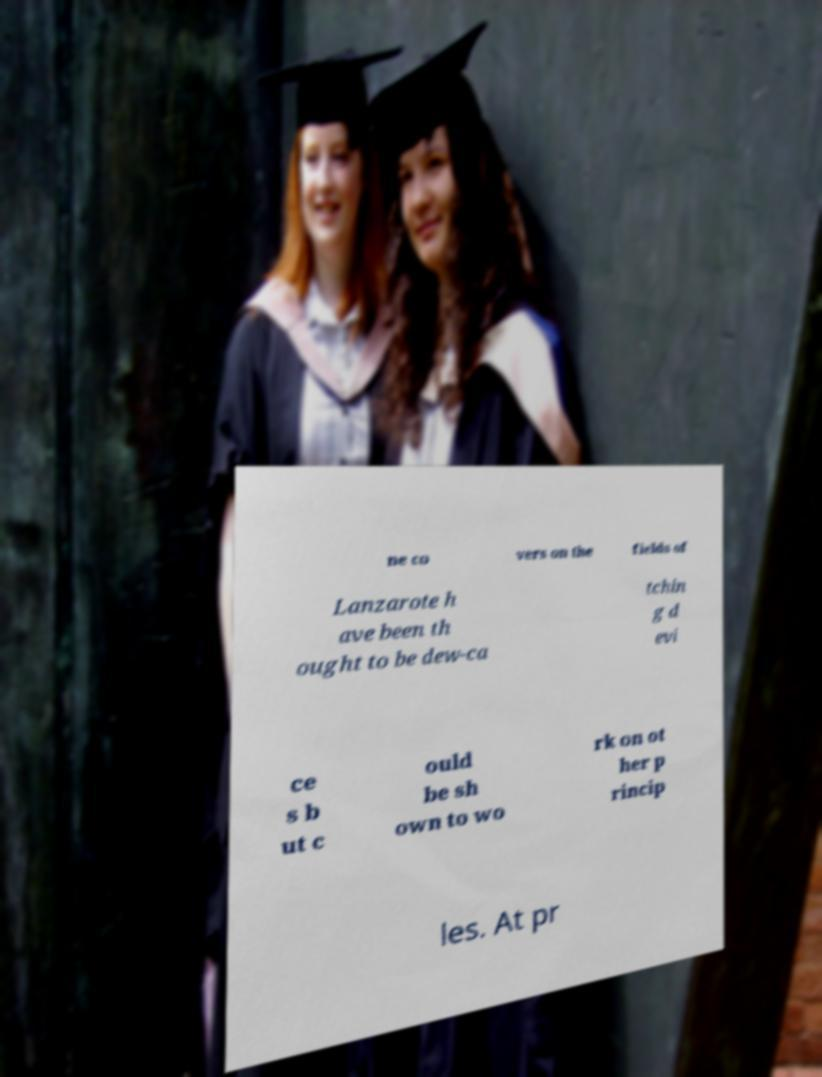I need the written content from this picture converted into text. Can you do that? ne co vers on the fields of Lanzarote h ave been th ought to be dew-ca tchin g d evi ce s b ut c ould be sh own to wo rk on ot her p rincip les. At pr 